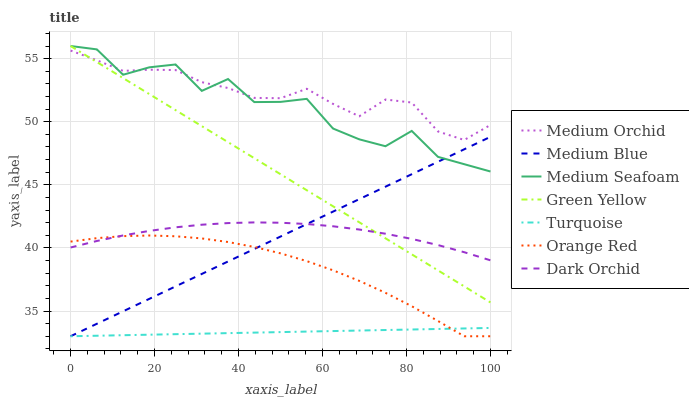Does Turquoise have the minimum area under the curve?
Answer yes or no. Yes. Does Medium Orchid have the maximum area under the curve?
Answer yes or no. Yes. Does Medium Blue have the minimum area under the curve?
Answer yes or no. No. Does Medium Blue have the maximum area under the curve?
Answer yes or no. No. Is Green Yellow the smoothest?
Answer yes or no. Yes. Is Medium Seafoam the roughest?
Answer yes or no. Yes. Is Medium Orchid the smoothest?
Answer yes or no. No. Is Medium Orchid the roughest?
Answer yes or no. No. Does Medium Orchid have the lowest value?
Answer yes or no. No. Does Medium Orchid have the highest value?
Answer yes or no. No. Is Turquoise less than Green Yellow?
Answer yes or no. Yes. Is Medium Orchid greater than Turquoise?
Answer yes or no. Yes. Does Turquoise intersect Green Yellow?
Answer yes or no. No. 